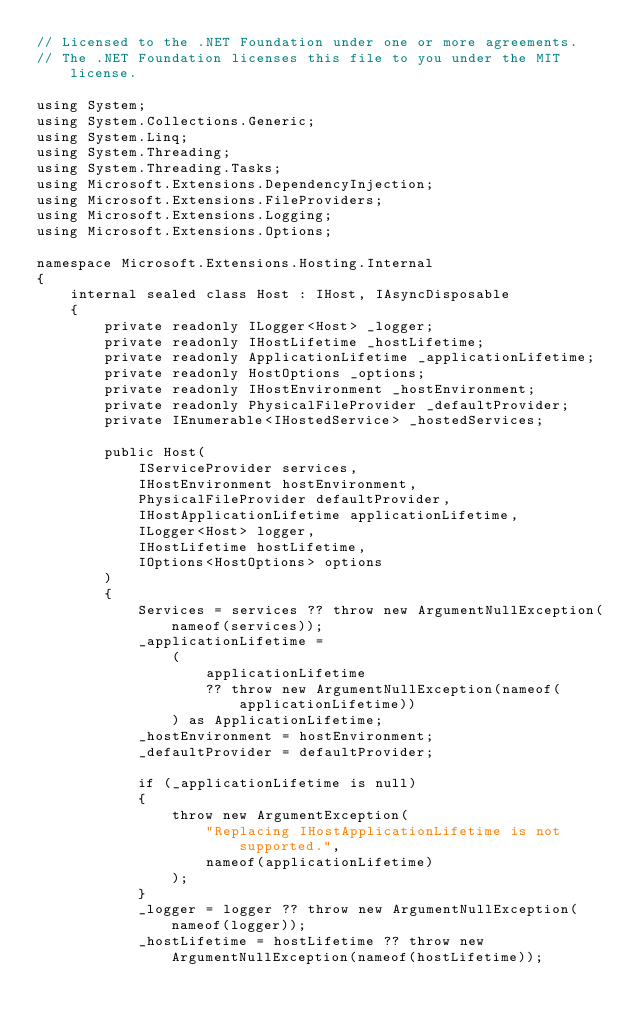Convert code to text. <code><loc_0><loc_0><loc_500><loc_500><_C#_>// Licensed to the .NET Foundation under one or more agreements.
// The .NET Foundation licenses this file to you under the MIT license.

using System;
using System.Collections.Generic;
using System.Linq;
using System.Threading;
using System.Threading.Tasks;
using Microsoft.Extensions.DependencyInjection;
using Microsoft.Extensions.FileProviders;
using Microsoft.Extensions.Logging;
using Microsoft.Extensions.Options;

namespace Microsoft.Extensions.Hosting.Internal
{
    internal sealed class Host : IHost, IAsyncDisposable
    {
        private readonly ILogger<Host> _logger;
        private readonly IHostLifetime _hostLifetime;
        private readonly ApplicationLifetime _applicationLifetime;
        private readonly HostOptions _options;
        private readonly IHostEnvironment _hostEnvironment;
        private readonly PhysicalFileProvider _defaultProvider;
        private IEnumerable<IHostedService> _hostedServices;

        public Host(
            IServiceProvider services,
            IHostEnvironment hostEnvironment,
            PhysicalFileProvider defaultProvider,
            IHostApplicationLifetime applicationLifetime,
            ILogger<Host> logger,
            IHostLifetime hostLifetime,
            IOptions<HostOptions> options
        )
        {
            Services = services ?? throw new ArgumentNullException(nameof(services));
            _applicationLifetime =
                (
                    applicationLifetime
                    ?? throw new ArgumentNullException(nameof(applicationLifetime))
                ) as ApplicationLifetime;
            _hostEnvironment = hostEnvironment;
            _defaultProvider = defaultProvider;

            if (_applicationLifetime is null)
            {
                throw new ArgumentException(
                    "Replacing IHostApplicationLifetime is not supported.",
                    nameof(applicationLifetime)
                );
            }
            _logger = logger ?? throw new ArgumentNullException(nameof(logger));
            _hostLifetime = hostLifetime ?? throw new ArgumentNullException(nameof(hostLifetime));</code> 